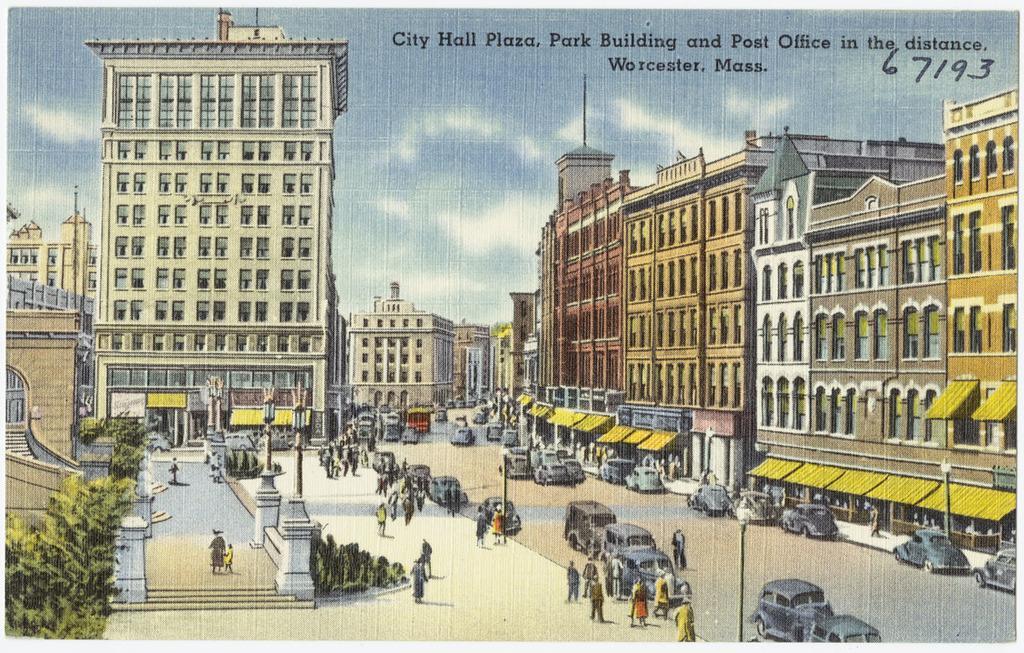Describe this image in one or two sentences. In this picture there is a poster in the center of the image, which includes buildings, trees, poles, and people in the image. 